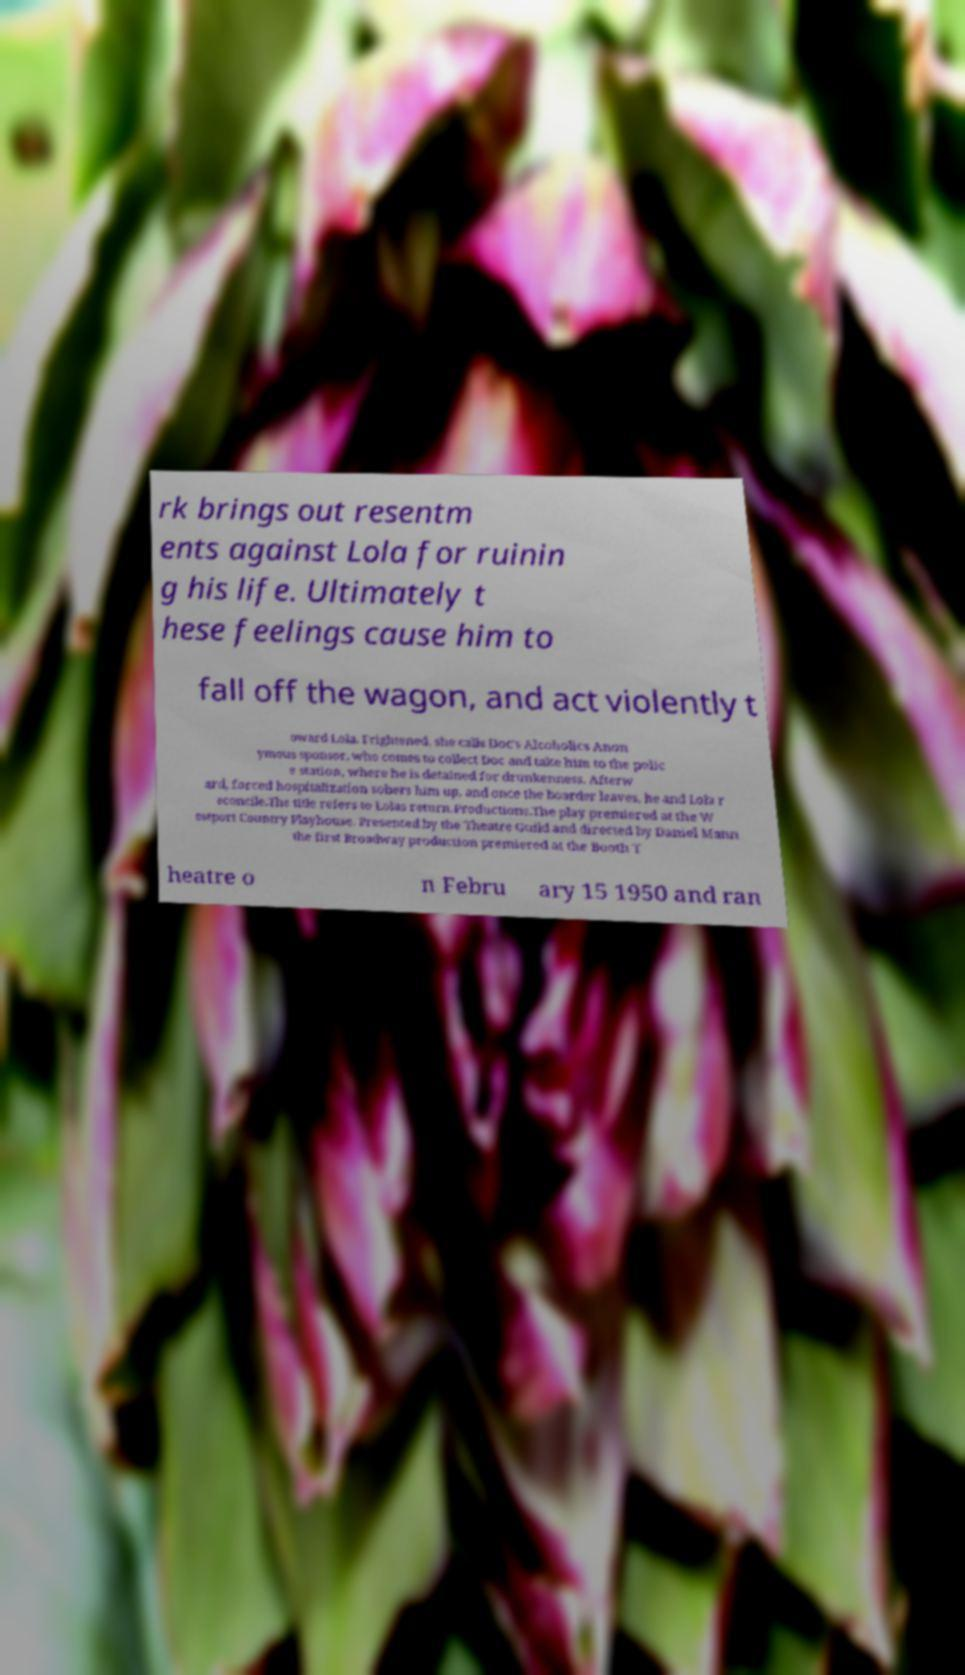Could you extract and type out the text from this image? rk brings out resentm ents against Lola for ruinin g his life. Ultimately t hese feelings cause him to fall off the wagon, and act violently t oward Lola. Frightened, she calls Doc's Alcoholics Anon ymous sponsor, who comes to collect Doc and take him to the polic e station, where he is detained for drunkenness. Afterw ard, forced hospitalization sobers him up, and once the boarder leaves, he and Lola r econcile.The title refers to Lolas return.Productions.The play premiered at the W estport Country Playhouse. Presented by the Theatre Guild and directed by Daniel Mann the first Broadway production premiered at the Booth T heatre o n Febru ary 15 1950 and ran 